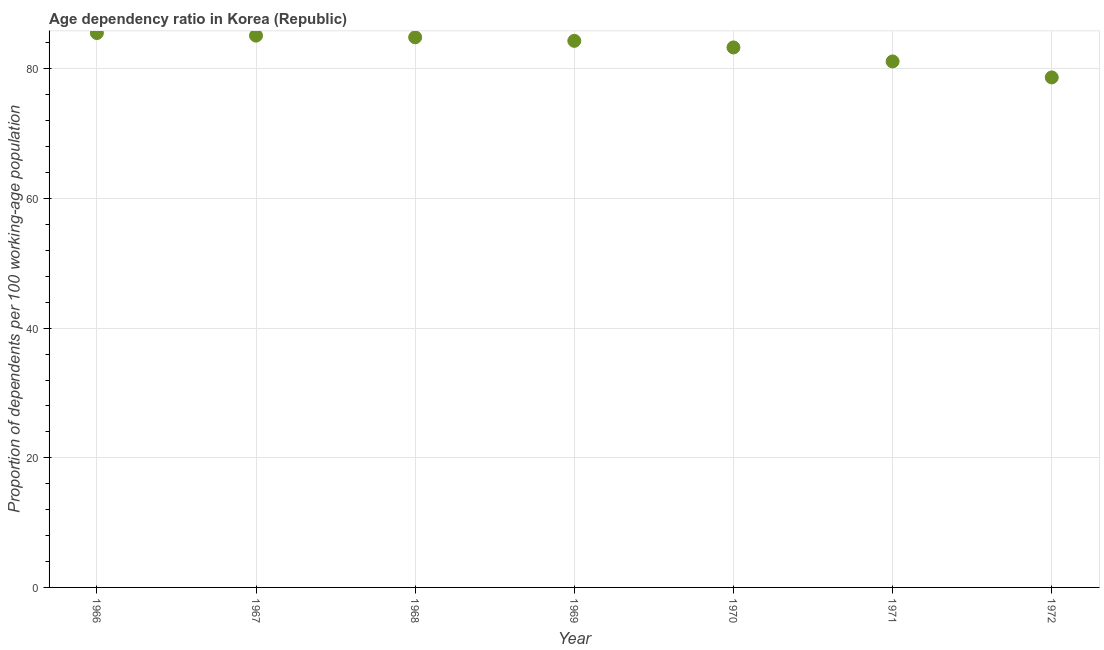What is the age dependency ratio in 1972?
Provide a succinct answer. 78.68. Across all years, what is the maximum age dependency ratio?
Keep it short and to the point. 85.53. Across all years, what is the minimum age dependency ratio?
Provide a short and direct response. 78.68. In which year was the age dependency ratio maximum?
Provide a succinct answer. 1966. What is the sum of the age dependency ratio?
Offer a terse response. 582.99. What is the difference between the age dependency ratio in 1967 and 1970?
Provide a short and direct response. 1.82. What is the average age dependency ratio per year?
Your answer should be very brief. 83.28. What is the median age dependency ratio?
Your answer should be compact. 84.32. In how many years, is the age dependency ratio greater than 20 ?
Make the answer very short. 7. What is the ratio of the age dependency ratio in 1969 to that in 1970?
Provide a short and direct response. 1.01. Is the difference between the age dependency ratio in 1968 and 1972 greater than the difference between any two years?
Your response must be concise. No. What is the difference between the highest and the second highest age dependency ratio?
Offer a terse response. 0.4. Is the sum of the age dependency ratio in 1966 and 1970 greater than the maximum age dependency ratio across all years?
Keep it short and to the point. Yes. What is the difference between the highest and the lowest age dependency ratio?
Make the answer very short. 6.85. In how many years, is the age dependency ratio greater than the average age dependency ratio taken over all years?
Make the answer very short. 5. Does the age dependency ratio monotonically increase over the years?
Make the answer very short. No. How many dotlines are there?
Provide a succinct answer. 1. Does the graph contain any zero values?
Ensure brevity in your answer.  No. Does the graph contain grids?
Make the answer very short. Yes. What is the title of the graph?
Your answer should be very brief. Age dependency ratio in Korea (Republic). What is the label or title of the Y-axis?
Offer a terse response. Proportion of dependents per 100 working-age population. What is the Proportion of dependents per 100 working-age population in 1966?
Keep it short and to the point. 85.53. What is the Proportion of dependents per 100 working-age population in 1967?
Provide a succinct answer. 85.13. What is the Proportion of dependents per 100 working-age population in 1968?
Provide a succinct answer. 84.87. What is the Proportion of dependents per 100 working-age population in 1969?
Offer a very short reply. 84.32. What is the Proportion of dependents per 100 working-age population in 1970?
Offer a terse response. 83.31. What is the Proportion of dependents per 100 working-age population in 1971?
Keep it short and to the point. 81.15. What is the Proportion of dependents per 100 working-age population in 1972?
Offer a terse response. 78.68. What is the difference between the Proportion of dependents per 100 working-age population in 1966 and 1967?
Provide a succinct answer. 0.4. What is the difference between the Proportion of dependents per 100 working-age population in 1966 and 1968?
Ensure brevity in your answer.  0.66. What is the difference between the Proportion of dependents per 100 working-age population in 1966 and 1969?
Provide a succinct answer. 1.2. What is the difference between the Proportion of dependents per 100 working-age population in 1966 and 1970?
Your response must be concise. 2.22. What is the difference between the Proportion of dependents per 100 working-age population in 1966 and 1971?
Offer a terse response. 4.38. What is the difference between the Proportion of dependents per 100 working-age population in 1966 and 1972?
Ensure brevity in your answer.  6.85. What is the difference between the Proportion of dependents per 100 working-age population in 1967 and 1968?
Your answer should be compact. 0.26. What is the difference between the Proportion of dependents per 100 working-age population in 1967 and 1969?
Offer a very short reply. 0.81. What is the difference between the Proportion of dependents per 100 working-age population in 1967 and 1970?
Your response must be concise. 1.82. What is the difference between the Proportion of dependents per 100 working-age population in 1967 and 1971?
Offer a terse response. 3.98. What is the difference between the Proportion of dependents per 100 working-age population in 1967 and 1972?
Provide a succinct answer. 6.45. What is the difference between the Proportion of dependents per 100 working-age population in 1968 and 1969?
Keep it short and to the point. 0.55. What is the difference between the Proportion of dependents per 100 working-age population in 1968 and 1970?
Make the answer very short. 1.56. What is the difference between the Proportion of dependents per 100 working-age population in 1968 and 1971?
Make the answer very short. 3.72. What is the difference between the Proportion of dependents per 100 working-age population in 1968 and 1972?
Your answer should be very brief. 6.19. What is the difference between the Proportion of dependents per 100 working-age population in 1969 and 1970?
Keep it short and to the point. 1.02. What is the difference between the Proportion of dependents per 100 working-age population in 1969 and 1971?
Ensure brevity in your answer.  3.18. What is the difference between the Proportion of dependents per 100 working-age population in 1969 and 1972?
Keep it short and to the point. 5.64. What is the difference between the Proportion of dependents per 100 working-age population in 1970 and 1971?
Your answer should be compact. 2.16. What is the difference between the Proportion of dependents per 100 working-age population in 1970 and 1972?
Your answer should be very brief. 4.63. What is the difference between the Proportion of dependents per 100 working-age population in 1971 and 1972?
Ensure brevity in your answer.  2.47. What is the ratio of the Proportion of dependents per 100 working-age population in 1966 to that in 1969?
Keep it short and to the point. 1.01. What is the ratio of the Proportion of dependents per 100 working-age population in 1966 to that in 1970?
Offer a very short reply. 1.03. What is the ratio of the Proportion of dependents per 100 working-age population in 1966 to that in 1971?
Your response must be concise. 1.05. What is the ratio of the Proportion of dependents per 100 working-age population in 1966 to that in 1972?
Keep it short and to the point. 1.09. What is the ratio of the Proportion of dependents per 100 working-age population in 1967 to that in 1969?
Your answer should be very brief. 1.01. What is the ratio of the Proportion of dependents per 100 working-age population in 1967 to that in 1970?
Your answer should be compact. 1.02. What is the ratio of the Proportion of dependents per 100 working-age population in 1967 to that in 1971?
Provide a succinct answer. 1.05. What is the ratio of the Proportion of dependents per 100 working-age population in 1967 to that in 1972?
Make the answer very short. 1.08. What is the ratio of the Proportion of dependents per 100 working-age population in 1968 to that in 1970?
Your response must be concise. 1.02. What is the ratio of the Proportion of dependents per 100 working-age population in 1968 to that in 1971?
Provide a short and direct response. 1.05. What is the ratio of the Proportion of dependents per 100 working-age population in 1968 to that in 1972?
Provide a short and direct response. 1.08. What is the ratio of the Proportion of dependents per 100 working-age population in 1969 to that in 1971?
Ensure brevity in your answer.  1.04. What is the ratio of the Proportion of dependents per 100 working-age population in 1969 to that in 1972?
Provide a short and direct response. 1.07. What is the ratio of the Proportion of dependents per 100 working-age population in 1970 to that in 1971?
Your answer should be very brief. 1.03. What is the ratio of the Proportion of dependents per 100 working-age population in 1970 to that in 1972?
Make the answer very short. 1.06. What is the ratio of the Proportion of dependents per 100 working-age population in 1971 to that in 1972?
Ensure brevity in your answer.  1.03. 